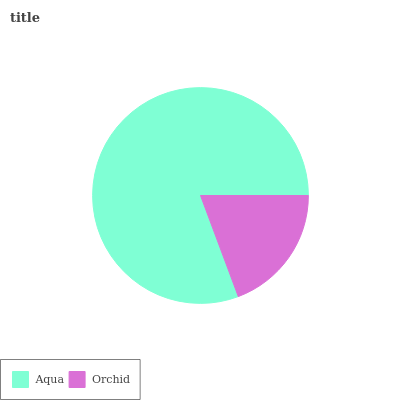Is Orchid the minimum?
Answer yes or no. Yes. Is Aqua the maximum?
Answer yes or no. Yes. Is Orchid the maximum?
Answer yes or no. No. Is Aqua greater than Orchid?
Answer yes or no. Yes. Is Orchid less than Aqua?
Answer yes or no. Yes. Is Orchid greater than Aqua?
Answer yes or no. No. Is Aqua less than Orchid?
Answer yes or no. No. Is Aqua the high median?
Answer yes or no. Yes. Is Orchid the low median?
Answer yes or no. Yes. Is Orchid the high median?
Answer yes or no. No. Is Aqua the low median?
Answer yes or no. No. 